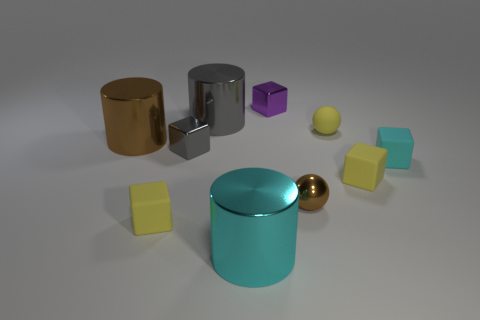Subtract all yellow blocks. How many were subtracted if there are1yellow blocks left? 1 Subtract 2 blocks. How many blocks are left? 3 Subtract all gray cubes. How many cubes are left? 4 Subtract all red blocks. Subtract all blue spheres. How many blocks are left? 5 Subtract all cylinders. How many objects are left? 7 Add 10 blue metallic things. How many blue metallic things exist? 10 Subtract 0 blue spheres. How many objects are left? 10 Subtract all big cyan shiny things. Subtract all small gray shiny blocks. How many objects are left? 8 Add 3 small gray cubes. How many small gray cubes are left? 4 